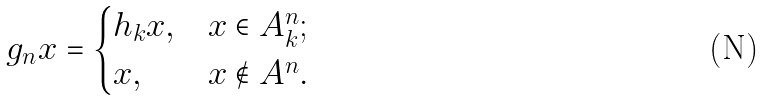<formula> <loc_0><loc_0><loc_500><loc_500>g _ { n } x = \begin{cases} h _ { k } x , & x \in A ^ { n } _ { k } ; \\ x , & x \notin A ^ { n } . \end{cases}</formula> 